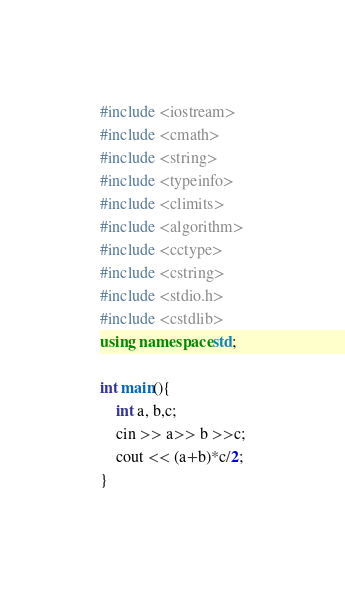<code> <loc_0><loc_0><loc_500><loc_500><_C++_>#include <iostream>
#include <cmath>
#include <string>
#include <typeinfo>
#include <climits>
#include <algorithm>
#include <cctype>
#include <cstring>
#include <stdio.h>
#include <cstdlib>
using namespace std;

int main(){
    int a, b,c;
    cin >> a>> b >>c;
    cout << (a+b)*c/2;
}</code> 